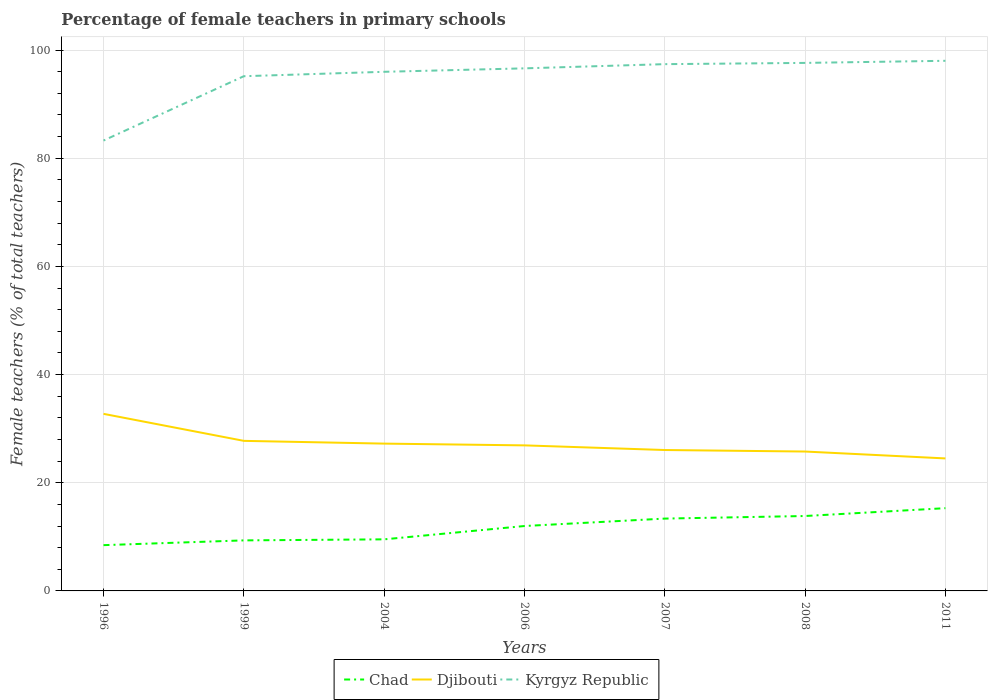Is the number of lines equal to the number of legend labels?
Give a very brief answer. Yes. Across all years, what is the maximum percentage of female teachers in Chad?
Offer a terse response. 8.46. What is the total percentage of female teachers in Kyrgyz Republic in the graph?
Offer a very short reply. -0.62. What is the difference between the highest and the second highest percentage of female teachers in Chad?
Provide a short and direct response. 6.84. What is the difference between the highest and the lowest percentage of female teachers in Kyrgyz Republic?
Offer a terse response. 6. How many years are there in the graph?
Make the answer very short. 7. What is the difference between two consecutive major ticks on the Y-axis?
Offer a terse response. 20. Does the graph contain any zero values?
Provide a succinct answer. No. Where does the legend appear in the graph?
Your answer should be compact. Bottom center. What is the title of the graph?
Offer a terse response. Percentage of female teachers in primary schools. Does "Sao Tome and Principe" appear as one of the legend labels in the graph?
Your response must be concise. No. What is the label or title of the Y-axis?
Your answer should be very brief. Female teachers (% of total teachers). What is the Female teachers (% of total teachers) in Chad in 1996?
Make the answer very short. 8.46. What is the Female teachers (% of total teachers) in Djibouti in 1996?
Ensure brevity in your answer.  32.74. What is the Female teachers (% of total teachers) of Kyrgyz Republic in 1996?
Your response must be concise. 83.26. What is the Female teachers (% of total teachers) of Chad in 1999?
Ensure brevity in your answer.  9.34. What is the Female teachers (% of total teachers) in Djibouti in 1999?
Make the answer very short. 27.74. What is the Female teachers (% of total teachers) in Kyrgyz Republic in 1999?
Your response must be concise. 95.15. What is the Female teachers (% of total teachers) in Chad in 2004?
Your answer should be compact. 9.54. What is the Female teachers (% of total teachers) of Djibouti in 2004?
Your answer should be compact. 27.23. What is the Female teachers (% of total teachers) of Kyrgyz Republic in 2004?
Make the answer very short. 95.97. What is the Female teachers (% of total teachers) of Chad in 2006?
Provide a short and direct response. 12. What is the Female teachers (% of total teachers) in Djibouti in 2006?
Provide a short and direct response. 26.91. What is the Female teachers (% of total teachers) in Kyrgyz Republic in 2006?
Your answer should be very brief. 96.61. What is the Female teachers (% of total teachers) in Chad in 2007?
Keep it short and to the point. 13.37. What is the Female teachers (% of total teachers) of Djibouti in 2007?
Your answer should be compact. 26.05. What is the Female teachers (% of total teachers) of Kyrgyz Republic in 2007?
Provide a short and direct response. 97.38. What is the Female teachers (% of total teachers) of Chad in 2008?
Provide a succinct answer. 13.85. What is the Female teachers (% of total teachers) of Djibouti in 2008?
Provide a succinct answer. 25.77. What is the Female teachers (% of total teachers) in Kyrgyz Republic in 2008?
Ensure brevity in your answer.  97.62. What is the Female teachers (% of total teachers) in Chad in 2011?
Ensure brevity in your answer.  15.3. What is the Female teachers (% of total teachers) of Djibouti in 2011?
Ensure brevity in your answer.  24.49. What is the Female teachers (% of total teachers) in Kyrgyz Republic in 2011?
Give a very brief answer. 98.01. Across all years, what is the maximum Female teachers (% of total teachers) in Chad?
Provide a short and direct response. 15.3. Across all years, what is the maximum Female teachers (% of total teachers) in Djibouti?
Give a very brief answer. 32.74. Across all years, what is the maximum Female teachers (% of total teachers) of Kyrgyz Republic?
Keep it short and to the point. 98.01. Across all years, what is the minimum Female teachers (% of total teachers) in Chad?
Your answer should be very brief. 8.46. Across all years, what is the minimum Female teachers (% of total teachers) of Djibouti?
Offer a very short reply. 24.49. Across all years, what is the minimum Female teachers (% of total teachers) in Kyrgyz Republic?
Your answer should be very brief. 83.26. What is the total Female teachers (% of total teachers) in Chad in the graph?
Offer a very short reply. 81.86. What is the total Female teachers (% of total teachers) in Djibouti in the graph?
Make the answer very short. 190.94. What is the total Female teachers (% of total teachers) in Kyrgyz Republic in the graph?
Keep it short and to the point. 664. What is the difference between the Female teachers (% of total teachers) in Chad in 1996 and that in 1999?
Your response must be concise. -0.88. What is the difference between the Female teachers (% of total teachers) in Djibouti in 1996 and that in 1999?
Ensure brevity in your answer.  4.99. What is the difference between the Female teachers (% of total teachers) of Kyrgyz Republic in 1996 and that in 1999?
Provide a succinct answer. -11.89. What is the difference between the Female teachers (% of total teachers) in Chad in 1996 and that in 2004?
Ensure brevity in your answer.  -1.07. What is the difference between the Female teachers (% of total teachers) of Djibouti in 1996 and that in 2004?
Provide a succinct answer. 5.5. What is the difference between the Female teachers (% of total teachers) of Kyrgyz Republic in 1996 and that in 2004?
Ensure brevity in your answer.  -12.71. What is the difference between the Female teachers (% of total teachers) in Chad in 1996 and that in 2006?
Your response must be concise. -3.54. What is the difference between the Female teachers (% of total teachers) of Djibouti in 1996 and that in 2006?
Provide a succinct answer. 5.83. What is the difference between the Female teachers (% of total teachers) of Kyrgyz Republic in 1996 and that in 2006?
Provide a succinct answer. -13.35. What is the difference between the Female teachers (% of total teachers) of Chad in 1996 and that in 2007?
Ensure brevity in your answer.  -4.91. What is the difference between the Female teachers (% of total teachers) in Djibouti in 1996 and that in 2007?
Your answer should be compact. 6.69. What is the difference between the Female teachers (% of total teachers) in Kyrgyz Republic in 1996 and that in 2007?
Provide a succinct answer. -14.12. What is the difference between the Female teachers (% of total teachers) in Chad in 1996 and that in 2008?
Keep it short and to the point. -5.39. What is the difference between the Female teachers (% of total teachers) in Djibouti in 1996 and that in 2008?
Offer a very short reply. 6.97. What is the difference between the Female teachers (% of total teachers) in Kyrgyz Republic in 1996 and that in 2008?
Give a very brief answer. -14.36. What is the difference between the Female teachers (% of total teachers) of Chad in 1996 and that in 2011?
Keep it short and to the point. -6.84. What is the difference between the Female teachers (% of total teachers) of Djibouti in 1996 and that in 2011?
Your response must be concise. 8.24. What is the difference between the Female teachers (% of total teachers) in Kyrgyz Republic in 1996 and that in 2011?
Provide a succinct answer. -14.75. What is the difference between the Female teachers (% of total teachers) in Chad in 1999 and that in 2004?
Give a very brief answer. -0.19. What is the difference between the Female teachers (% of total teachers) of Djibouti in 1999 and that in 2004?
Give a very brief answer. 0.51. What is the difference between the Female teachers (% of total teachers) in Kyrgyz Republic in 1999 and that in 2004?
Your answer should be compact. -0.82. What is the difference between the Female teachers (% of total teachers) of Chad in 1999 and that in 2006?
Provide a succinct answer. -2.66. What is the difference between the Female teachers (% of total teachers) in Djibouti in 1999 and that in 2006?
Give a very brief answer. 0.83. What is the difference between the Female teachers (% of total teachers) of Kyrgyz Republic in 1999 and that in 2006?
Your answer should be very brief. -1.45. What is the difference between the Female teachers (% of total teachers) of Chad in 1999 and that in 2007?
Ensure brevity in your answer.  -4.03. What is the difference between the Female teachers (% of total teachers) in Djibouti in 1999 and that in 2007?
Make the answer very short. 1.69. What is the difference between the Female teachers (% of total teachers) in Kyrgyz Republic in 1999 and that in 2007?
Provide a succinct answer. -2.23. What is the difference between the Female teachers (% of total teachers) in Chad in 1999 and that in 2008?
Offer a terse response. -4.51. What is the difference between the Female teachers (% of total teachers) in Djibouti in 1999 and that in 2008?
Ensure brevity in your answer.  1.97. What is the difference between the Female teachers (% of total teachers) of Kyrgyz Republic in 1999 and that in 2008?
Give a very brief answer. -2.46. What is the difference between the Female teachers (% of total teachers) of Chad in 1999 and that in 2011?
Provide a succinct answer. -5.96. What is the difference between the Female teachers (% of total teachers) in Djibouti in 1999 and that in 2011?
Your response must be concise. 3.25. What is the difference between the Female teachers (% of total teachers) in Kyrgyz Republic in 1999 and that in 2011?
Provide a succinct answer. -2.85. What is the difference between the Female teachers (% of total teachers) of Chad in 2004 and that in 2006?
Provide a short and direct response. -2.46. What is the difference between the Female teachers (% of total teachers) in Djibouti in 2004 and that in 2006?
Make the answer very short. 0.33. What is the difference between the Female teachers (% of total teachers) of Kyrgyz Republic in 2004 and that in 2006?
Your answer should be compact. -0.64. What is the difference between the Female teachers (% of total teachers) in Chad in 2004 and that in 2007?
Ensure brevity in your answer.  -3.84. What is the difference between the Female teachers (% of total teachers) in Djibouti in 2004 and that in 2007?
Ensure brevity in your answer.  1.19. What is the difference between the Female teachers (% of total teachers) in Kyrgyz Republic in 2004 and that in 2007?
Provide a succinct answer. -1.41. What is the difference between the Female teachers (% of total teachers) of Chad in 2004 and that in 2008?
Offer a very short reply. -4.31. What is the difference between the Female teachers (% of total teachers) of Djibouti in 2004 and that in 2008?
Your answer should be very brief. 1.46. What is the difference between the Female teachers (% of total teachers) of Kyrgyz Republic in 2004 and that in 2008?
Your response must be concise. -1.64. What is the difference between the Female teachers (% of total teachers) in Chad in 2004 and that in 2011?
Your answer should be very brief. -5.76. What is the difference between the Female teachers (% of total teachers) in Djibouti in 2004 and that in 2011?
Offer a terse response. 2.74. What is the difference between the Female teachers (% of total teachers) in Kyrgyz Republic in 2004 and that in 2011?
Provide a short and direct response. -2.03. What is the difference between the Female teachers (% of total teachers) in Chad in 2006 and that in 2007?
Offer a very short reply. -1.37. What is the difference between the Female teachers (% of total teachers) of Djibouti in 2006 and that in 2007?
Give a very brief answer. 0.86. What is the difference between the Female teachers (% of total teachers) in Kyrgyz Republic in 2006 and that in 2007?
Offer a very short reply. -0.78. What is the difference between the Female teachers (% of total teachers) of Chad in 2006 and that in 2008?
Make the answer very short. -1.85. What is the difference between the Female teachers (% of total teachers) of Djibouti in 2006 and that in 2008?
Keep it short and to the point. 1.14. What is the difference between the Female teachers (% of total teachers) in Kyrgyz Republic in 2006 and that in 2008?
Your answer should be compact. -1.01. What is the difference between the Female teachers (% of total teachers) in Chad in 2006 and that in 2011?
Your answer should be very brief. -3.3. What is the difference between the Female teachers (% of total teachers) in Djibouti in 2006 and that in 2011?
Make the answer very short. 2.41. What is the difference between the Female teachers (% of total teachers) of Kyrgyz Republic in 2006 and that in 2011?
Your response must be concise. -1.4. What is the difference between the Female teachers (% of total teachers) in Chad in 2007 and that in 2008?
Offer a terse response. -0.48. What is the difference between the Female teachers (% of total teachers) of Djibouti in 2007 and that in 2008?
Your answer should be very brief. 0.28. What is the difference between the Female teachers (% of total teachers) in Kyrgyz Republic in 2007 and that in 2008?
Your response must be concise. -0.23. What is the difference between the Female teachers (% of total teachers) of Chad in 2007 and that in 2011?
Provide a succinct answer. -1.93. What is the difference between the Female teachers (% of total teachers) in Djibouti in 2007 and that in 2011?
Provide a short and direct response. 1.55. What is the difference between the Female teachers (% of total teachers) of Kyrgyz Republic in 2007 and that in 2011?
Provide a short and direct response. -0.62. What is the difference between the Female teachers (% of total teachers) of Chad in 2008 and that in 2011?
Ensure brevity in your answer.  -1.45. What is the difference between the Female teachers (% of total teachers) in Djibouti in 2008 and that in 2011?
Your answer should be very brief. 1.27. What is the difference between the Female teachers (% of total teachers) of Kyrgyz Republic in 2008 and that in 2011?
Ensure brevity in your answer.  -0.39. What is the difference between the Female teachers (% of total teachers) in Chad in 1996 and the Female teachers (% of total teachers) in Djibouti in 1999?
Your response must be concise. -19.28. What is the difference between the Female teachers (% of total teachers) of Chad in 1996 and the Female teachers (% of total teachers) of Kyrgyz Republic in 1999?
Keep it short and to the point. -86.69. What is the difference between the Female teachers (% of total teachers) of Djibouti in 1996 and the Female teachers (% of total teachers) of Kyrgyz Republic in 1999?
Offer a very short reply. -62.42. What is the difference between the Female teachers (% of total teachers) in Chad in 1996 and the Female teachers (% of total teachers) in Djibouti in 2004?
Your response must be concise. -18.77. What is the difference between the Female teachers (% of total teachers) in Chad in 1996 and the Female teachers (% of total teachers) in Kyrgyz Republic in 2004?
Give a very brief answer. -87.51. What is the difference between the Female teachers (% of total teachers) of Djibouti in 1996 and the Female teachers (% of total teachers) of Kyrgyz Republic in 2004?
Your response must be concise. -63.23. What is the difference between the Female teachers (% of total teachers) in Chad in 1996 and the Female teachers (% of total teachers) in Djibouti in 2006?
Provide a succinct answer. -18.45. What is the difference between the Female teachers (% of total teachers) of Chad in 1996 and the Female teachers (% of total teachers) of Kyrgyz Republic in 2006?
Offer a terse response. -88.15. What is the difference between the Female teachers (% of total teachers) of Djibouti in 1996 and the Female teachers (% of total teachers) of Kyrgyz Republic in 2006?
Offer a very short reply. -63.87. What is the difference between the Female teachers (% of total teachers) of Chad in 1996 and the Female teachers (% of total teachers) of Djibouti in 2007?
Provide a short and direct response. -17.59. What is the difference between the Female teachers (% of total teachers) in Chad in 1996 and the Female teachers (% of total teachers) in Kyrgyz Republic in 2007?
Offer a terse response. -88.92. What is the difference between the Female teachers (% of total teachers) of Djibouti in 1996 and the Female teachers (% of total teachers) of Kyrgyz Republic in 2007?
Your answer should be very brief. -64.65. What is the difference between the Female teachers (% of total teachers) of Chad in 1996 and the Female teachers (% of total teachers) of Djibouti in 2008?
Give a very brief answer. -17.31. What is the difference between the Female teachers (% of total teachers) of Chad in 1996 and the Female teachers (% of total teachers) of Kyrgyz Republic in 2008?
Provide a succinct answer. -89.15. What is the difference between the Female teachers (% of total teachers) in Djibouti in 1996 and the Female teachers (% of total teachers) in Kyrgyz Republic in 2008?
Make the answer very short. -64.88. What is the difference between the Female teachers (% of total teachers) of Chad in 1996 and the Female teachers (% of total teachers) of Djibouti in 2011?
Your answer should be compact. -16.03. What is the difference between the Female teachers (% of total teachers) in Chad in 1996 and the Female teachers (% of total teachers) in Kyrgyz Republic in 2011?
Provide a short and direct response. -89.54. What is the difference between the Female teachers (% of total teachers) of Djibouti in 1996 and the Female teachers (% of total teachers) of Kyrgyz Republic in 2011?
Give a very brief answer. -65.27. What is the difference between the Female teachers (% of total teachers) of Chad in 1999 and the Female teachers (% of total teachers) of Djibouti in 2004?
Ensure brevity in your answer.  -17.89. What is the difference between the Female teachers (% of total teachers) in Chad in 1999 and the Female teachers (% of total teachers) in Kyrgyz Republic in 2004?
Make the answer very short. -86.63. What is the difference between the Female teachers (% of total teachers) in Djibouti in 1999 and the Female teachers (% of total teachers) in Kyrgyz Republic in 2004?
Provide a succinct answer. -68.23. What is the difference between the Female teachers (% of total teachers) of Chad in 1999 and the Female teachers (% of total teachers) of Djibouti in 2006?
Your answer should be very brief. -17.57. What is the difference between the Female teachers (% of total teachers) in Chad in 1999 and the Female teachers (% of total teachers) in Kyrgyz Republic in 2006?
Give a very brief answer. -87.27. What is the difference between the Female teachers (% of total teachers) of Djibouti in 1999 and the Female teachers (% of total teachers) of Kyrgyz Republic in 2006?
Keep it short and to the point. -68.87. What is the difference between the Female teachers (% of total teachers) of Chad in 1999 and the Female teachers (% of total teachers) of Djibouti in 2007?
Offer a very short reply. -16.71. What is the difference between the Female teachers (% of total teachers) in Chad in 1999 and the Female teachers (% of total teachers) in Kyrgyz Republic in 2007?
Your answer should be very brief. -88.04. What is the difference between the Female teachers (% of total teachers) in Djibouti in 1999 and the Female teachers (% of total teachers) in Kyrgyz Republic in 2007?
Your answer should be compact. -69.64. What is the difference between the Female teachers (% of total teachers) of Chad in 1999 and the Female teachers (% of total teachers) of Djibouti in 2008?
Your answer should be compact. -16.43. What is the difference between the Female teachers (% of total teachers) of Chad in 1999 and the Female teachers (% of total teachers) of Kyrgyz Republic in 2008?
Make the answer very short. -88.27. What is the difference between the Female teachers (% of total teachers) in Djibouti in 1999 and the Female teachers (% of total teachers) in Kyrgyz Republic in 2008?
Provide a succinct answer. -69.87. What is the difference between the Female teachers (% of total teachers) of Chad in 1999 and the Female teachers (% of total teachers) of Djibouti in 2011?
Make the answer very short. -15.15. What is the difference between the Female teachers (% of total teachers) in Chad in 1999 and the Female teachers (% of total teachers) in Kyrgyz Republic in 2011?
Your answer should be very brief. -88.66. What is the difference between the Female teachers (% of total teachers) in Djibouti in 1999 and the Female teachers (% of total teachers) in Kyrgyz Republic in 2011?
Your answer should be very brief. -70.26. What is the difference between the Female teachers (% of total teachers) of Chad in 2004 and the Female teachers (% of total teachers) of Djibouti in 2006?
Ensure brevity in your answer.  -17.37. What is the difference between the Female teachers (% of total teachers) in Chad in 2004 and the Female teachers (% of total teachers) in Kyrgyz Republic in 2006?
Your answer should be very brief. -87.07. What is the difference between the Female teachers (% of total teachers) of Djibouti in 2004 and the Female teachers (% of total teachers) of Kyrgyz Republic in 2006?
Make the answer very short. -69.37. What is the difference between the Female teachers (% of total teachers) of Chad in 2004 and the Female teachers (% of total teachers) of Djibouti in 2007?
Your answer should be very brief. -16.51. What is the difference between the Female teachers (% of total teachers) of Chad in 2004 and the Female teachers (% of total teachers) of Kyrgyz Republic in 2007?
Provide a short and direct response. -87.85. What is the difference between the Female teachers (% of total teachers) in Djibouti in 2004 and the Female teachers (% of total teachers) in Kyrgyz Republic in 2007?
Provide a short and direct response. -70.15. What is the difference between the Female teachers (% of total teachers) in Chad in 2004 and the Female teachers (% of total teachers) in Djibouti in 2008?
Offer a very short reply. -16.23. What is the difference between the Female teachers (% of total teachers) of Chad in 2004 and the Female teachers (% of total teachers) of Kyrgyz Republic in 2008?
Give a very brief answer. -88.08. What is the difference between the Female teachers (% of total teachers) of Djibouti in 2004 and the Female teachers (% of total teachers) of Kyrgyz Republic in 2008?
Your response must be concise. -70.38. What is the difference between the Female teachers (% of total teachers) of Chad in 2004 and the Female teachers (% of total teachers) of Djibouti in 2011?
Provide a succinct answer. -14.96. What is the difference between the Female teachers (% of total teachers) of Chad in 2004 and the Female teachers (% of total teachers) of Kyrgyz Republic in 2011?
Make the answer very short. -88.47. What is the difference between the Female teachers (% of total teachers) in Djibouti in 2004 and the Female teachers (% of total teachers) in Kyrgyz Republic in 2011?
Your response must be concise. -70.77. What is the difference between the Female teachers (% of total teachers) of Chad in 2006 and the Female teachers (% of total teachers) of Djibouti in 2007?
Keep it short and to the point. -14.05. What is the difference between the Female teachers (% of total teachers) in Chad in 2006 and the Female teachers (% of total teachers) in Kyrgyz Republic in 2007?
Give a very brief answer. -85.39. What is the difference between the Female teachers (% of total teachers) in Djibouti in 2006 and the Female teachers (% of total teachers) in Kyrgyz Republic in 2007?
Offer a terse response. -70.48. What is the difference between the Female teachers (% of total teachers) of Chad in 2006 and the Female teachers (% of total teachers) of Djibouti in 2008?
Ensure brevity in your answer.  -13.77. What is the difference between the Female teachers (% of total teachers) of Chad in 2006 and the Female teachers (% of total teachers) of Kyrgyz Republic in 2008?
Keep it short and to the point. -85.62. What is the difference between the Female teachers (% of total teachers) in Djibouti in 2006 and the Female teachers (% of total teachers) in Kyrgyz Republic in 2008?
Keep it short and to the point. -70.71. What is the difference between the Female teachers (% of total teachers) in Chad in 2006 and the Female teachers (% of total teachers) in Djibouti in 2011?
Your response must be concise. -12.5. What is the difference between the Female teachers (% of total teachers) in Chad in 2006 and the Female teachers (% of total teachers) in Kyrgyz Republic in 2011?
Your answer should be compact. -86.01. What is the difference between the Female teachers (% of total teachers) in Djibouti in 2006 and the Female teachers (% of total teachers) in Kyrgyz Republic in 2011?
Offer a terse response. -71.1. What is the difference between the Female teachers (% of total teachers) of Chad in 2007 and the Female teachers (% of total teachers) of Djibouti in 2008?
Make the answer very short. -12.4. What is the difference between the Female teachers (% of total teachers) of Chad in 2007 and the Female teachers (% of total teachers) of Kyrgyz Republic in 2008?
Your answer should be compact. -84.24. What is the difference between the Female teachers (% of total teachers) in Djibouti in 2007 and the Female teachers (% of total teachers) in Kyrgyz Republic in 2008?
Keep it short and to the point. -71.57. What is the difference between the Female teachers (% of total teachers) in Chad in 2007 and the Female teachers (% of total teachers) in Djibouti in 2011?
Keep it short and to the point. -11.12. What is the difference between the Female teachers (% of total teachers) of Chad in 2007 and the Female teachers (% of total teachers) of Kyrgyz Republic in 2011?
Your answer should be compact. -84.63. What is the difference between the Female teachers (% of total teachers) of Djibouti in 2007 and the Female teachers (% of total teachers) of Kyrgyz Republic in 2011?
Your response must be concise. -71.96. What is the difference between the Female teachers (% of total teachers) of Chad in 2008 and the Female teachers (% of total teachers) of Djibouti in 2011?
Provide a short and direct response. -10.65. What is the difference between the Female teachers (% of total teachers) in Chad in 2008 and the Female teachers (% of total teachers) in Kyrgyz Republic in 2011?
Provide a succinct answer. -84.16. What is the difference between the Female teachers (% of total teachers) of Djibouti in 2008 and the Female teachers (% of total teachers) of Kyrgyz Republic in 2011?
Provide a short and direct response. -72.24. What is the average Female teachers (% of total teachers) of Chad per year?
Ensure brevity in your answer.  11.69. What is the average Female teachers (% of total teachers) in Djibouti per year?
Make the answer very short. 27.28. What is the average Female teachers (% of total teachers) of Kyrgyz Republic per year?
Offer a terse response. 94.86. In the year 1996, what is the difference between the Female teachers (% of total teachers) of Chad and Female teachers (% of total teachers) of Djibouti?
Give a very brief answer. -24.27. In the year 1996, what is the difference between the Female teachers (% of total teachers) in Chad and Female teachers (% of total teachers) in Kyrgyz Republic?
Your answer should be compact. -74.8. In the year 1996, what is the difference between the Female teachers (% of total teachers) of Djibouti and Female teachers (% of total teachers) of Kyrgyz Republic?
Your answer should be very brief. -50.52. In the year 1999, what is the difference between the Female teachers (% of total teachers) in Chad and Female teachers (% of total teachers) in Djibouti?
Keep it short and to the point. -18.4. In the year 1999, what is the difference between the Female teachers (% of total teachers) of Chad and Female teachers (% of total teachers) of Kyrgyz Republic?
Offer a terse response. -85.81. In the year 1999, what is the difference between the Female teachers (% of total teachers) in Djibouti and Female teachers (% of total teachers) in Kyrgyz Republic?
Offer a terse response. -67.41. In the year 2004, what is the difference between the Female teachers (% of total teachers) of Chad and Female teachers (% of total teachers) of Djibouti?
Make the answer very short. -17.7. In the year 2004, what is the difference between the Female teachers (% of total teachers) in Chad and Female teachers (% of total teachers) in Kyrgyz Republic?
Give a very brief answer. -86.44. In the year 2004, what is the difference between the Female teachers (% of total teachers) in Djibouti and Female teachers (% of total teachers) in Kyrgyz Republic?
Provide a short and direct response. -68.74. In the year 2006, what is the difference between the Female teachers (% of total teachers) in Chad and Female teachers (% of total teachers) in Djibouti?
Ensure brevity in your answer.  -14.91. In the year 2006, what is the difference between the Female teachers (% of total teachers) in Chad and Female teachers (% of total teachers) in Kyrgyz Republic?
Your answer should be compact. -84.61. In the year 2006, what is the difference between the Female teachers (% of total teachers) in Djibouti and Female teachers (% of total teachers) in Kyrgyz Republic?
Offer a terse response. -69.7. In the year 2007, what is the difference between the Female teachers (% of total teachers) in Chad and Female teachers (% of total teachers) in Djibouti?
Offer a terse response. -12.68. In the year 2007, what is the difference between the Female teachers (% of total teachers) in Chad and Female teachers (% of total teachers) in Kyrgyz Republic?
Provide a succinct answer. -84.01. In the year 2007, what is the difference between the Female teachers (% of total teachers) of Djibouti and Female teachers (% of total teachers) of Kyrgyz Republic?
Ensure brevity in your answer.  -71.34. In the year 2008, what is the difference between the Female teachers (% of total teachers) of Chad and Female teachers (% of total teachers) of Djibouti?
Provide a succinct answer. -11.92. In the year 2008, what is the difference between the Female teachers (% of total teachers) of Chad and Female teachers (% of total teachers) of Kyrgyz Republic?
Your response must be concise. -83.77. In the year 2008, what is the difference between the Female teachers (% of total teachers) of Djibouti and Female teachers (% of total teachers) of Kyrgyz Republic?
Offer a very short reply. -71.85. In the year 2011, what is the difference between the Female teachers (% of total teachers) of Chad and Female teachers (% of total teachers) of Djibouti?
Provide a succinct answer. -9.2. In the year 2011, what is the difference between the Female teachers (% of total teachers) in Chad and Female teachers (% of total teachers) in Kyrgyz Republic?
Offer a very short reply. -82.71. In the year 2011, what is the difference between the Female teachers (% of total teachers) in Djibouti and Female teachers (% of total teachers) in Kyrgyz Republic?
Make the answer very short. -73.51. What is the ratio of the Female teachers (% of total teachers) of Chad in 1996 to that in 1999?
Make the answer very short. 0.91. What is the ratio of the Female teachers (% of total teachers) in Djibouti in 1996 to that in 1999?
Offer a very short reply. 1.18. What is the ratio of the Female teachers (% of total teachers) in Kyrgyz Republic in 1996 to that in 1999?
Your answer should be compact. 0.88. What is the ratio of the Female teachers (% of total teachers) in Chad in 1996 to that in 2004?
Make the answer very short. 0.89. What is the ratio of the Female teachers (% of total teachers) of Djibouti in 1996 to that in 2004?
Make the answer very short. 1.2. What is the ratio of the Female teachers (% of total teachers) in Kyrgyz Republic in 1996 to that in 2004?
Give a very brief answer. 0.87. What is the ratio of the Female teachers (% of total teachers) of Chad in 1996 to that in 2006?
Make the answer very short. 0.71. What is the ratio of the Female teachers (% of total teachers) of Djibouti in 1996 to that in 2006?
Provide a short and direct response. 1.22. What is the ratio of the Female teachers (% of total teachers) in Kyrgyz Republic in 1996 to that in 2006?
Provide a short and direct response. 0.86. What is the ratio of the Female teachers (% of total teachers) in Chad in 1996 to that in 2007?
Your answer should be compact. 0.63. What is the ratio of the Female teachers (% of total teachers) of Djibouti in 1996 to that in 2007?
Offer a terse response. 1.26. What is the ratio of the Female teachers (% of total teachers) of Kyrgyz Republic in 1996 to that in 2007?
Offer a terse response. 0.85. What is the ratio of the Female teachers (% of total teachers) of Chad in 1996 to that in 2008?
Your response must be concise. 0.61. What is the ratio of the Female teachers (% of total teachers) in Djibouti in 1996 to that in 2008?
Give a very brief answer. 1.27. What is the ratio of the Female teachers (% of total teachers) in Kyrgyz Republic in 1996 to that in 2008?
Your answer should be compact. 0.85. What is the ratio of the Female teachers (% of total teachers) in Chad in 1996 to that in 2011?
Ensure brevity in your answer.  0.55. What is the ratio of the Female teachers (% of total teachers) in Djibouti in 1996 to that in 2011?
Your response must be concise. 1.34. What is the ratio of the Female teachers (% of total teachers) in Kyrgyz Republic in 1996 to that in 2011?
Provide a succinct answer. 0.85. What is the ratio of the Female teachers (% of total teachers) in Chad in 1999 to that in 2004?
Your response must be concise. 0.98. What is the ratio of the Female teachers (% of total teachers) in Djibouti in 1999 to that in 2004?
Give a very brief answer. 1.02. What is the ratio of the Female teachers (% of total teachers) in Kyrgyz Republic in 1999 to that in 2004?
Give a very brief answer. 0.99. What is the ratio of the Female teachers (% of total teachers) of Chad in 1999 to that in 2006?
Offer a very short reply. 0.78. What is the ratio of the Female teachers (% of total teachers) in Djibouti in 1999 to that in 2006?
Your answer should be compact. 1.03. What is the ratio of the Female teachers (% of total teachers) in Kyrgyz Republic in 1999 to that in 2006?
Give a very brief answer. 0.98. What is the ratio of the Female teachers (% of total teachers) of Chad in 1999 to that in 2007?
Keep it short and to the point. 0.7. What is the ratio of the Female teachers (% of total teachers) of Djibouti in 1999 to that in 2007?
Your answer should be compact. 1.06. What is the ratio of the Female teachers (% of total teachers) of Kyrgyz Republic in 1999 to that in 2007?
Give a very brief answer. 0.98. What is the ratio of the Female teachers (% of total teachers) of Chad in 1999 to that in 2008?
Make the answer very short. 0.67. What is the ratio of the Female teachers (% of total teachers) of Djibouti in 1999 to that in 2008?
Give a very brief answer. 1.08. What is the ratio of the Female teachers (% of total teachers) in Kyrgyz Republic in 1999 to that in 2008?
Provide a short and direct response. 0.97. What is the ratio of the Female teachers (% of total teachers) of Chad in 1999 to that in 2011?
Your answer should be compact. 0.61. What is the ratio of the Female teachers (% of total teachers) in Djibouti in 1999 to that in 2011?
Ensure brevity in your answer.  1.13. What is the ratio of the Female teachers (% of total teachers) in Kyrgyz Republic in 1999 to that in 2011?
Keep it short and to the point. 0.97. What is the ratio of the Female teachers (% of total teachers) of Chad in 2004 to that in 2006?
Make the answer very short. 0.79. What is the ratio of the Female teachers (% of total teachers) of Djibouti in 2004 to that in 2006?
Your response must be concise. 1.01. What is the ratio of the Female teachers (% of total teachers) of Kyrgyz Republic in 2004 to that in 2006?
Provide a succinct answer. 0.99. What is the ratio of the Female teachers (% of total teachers) of Chad in 2004 to that in 2007?
Your answer should be very brief. 0.71. What is the ratio of the Female teachers (% of total teachers) of Djibouti in 2004 to that in 2007?
Your response must be concise. 1.05. What is the ratio of the Female teachers (% of total teachers) of Kyrgyz Republic in 2004 to that in 2007?
Your answer should be very brief. 0.99. What is the ratio of the Female teachers (% of total teachers) of Chad in 2004 to that in 2008?
Make the answer very short. 0.69. What is the ratio of the Female teachers (% of total teachers) of Djibouti in 2004 to that in 2008?
Your answer should be compact. 1.06. What is the ratio of the Female teachers (% of total teachers) of Kyrgyz Republic in 2004 to that in 2008?
Give a very brief answer. 0.98. What is the ratio of the Female teachers (% of total teachers) of Chad in 2004 to that in 2011?
Make the answer very short. 0.62. What is the ratio of the Female teachers (% of total teachers) in Djibouti in 2004 to that in 2011?
Provide a short and direct response. 1.11. What is the ratio of the Female teachers (% of total teachers) in Kyrgyz Republic in 2004 to that in 2011?
Your answer should be very brief. 0.98. What is the ratio of the Female teachers (% of total teachers) of Chad in 2006 to that in 2007?
Ensure brevity in your answer.  0.9. What is the ratio of the Female teachers (% of total teachers) in Djibouti in 2006 to that in 2007?
Offer a very short reply. 1.03. What is the ratio of the Female teachers (% of total teachers) of Chad in 2006 to that in 2008?
Keep it short and to the point. 0.87. What is the ratio of the Female teachers (% of total teachers) of Djibouti in 2006 to that in 2008?
Your answer should be very brief. 1.04. What is the ratio of the Female teachers (% of total teachers) of Kyrgyz Republic in 2006 to that in 2008?
Provide a short and direct response. 0.99. What is the ratio of the Female teachers (% of total teachers) of Chad in 2006 to that in 2011?
Offer a very short reply. 0.78. What is the ratio of the Female teachers (% of total teachers) of Djibouti in 2006 to that in 2011?
Make the answer very short. 1.1. What is the ratio of the Female teachers (% of total teachers) in Kyrgyz Republic in 2006 to that in 2011?
Ensure brevity in your answer.  0.99. What is the ratio of the Female teachers (% of total teachers) of Chad in 2007 to that in 2008?
Provide a short and direct response. 0.97. What is the ratio of the Female teachers (% of total teachers) in Djibouti in 2007 to that in 2008?
Your answer should be compact. 1.01. What is the ratio of the Female teachers (% of total teachers) of Kyrgyz Republic in 2007 to that in 2008?
Give a very brief answer. 1. What is the ratio of the Female teachers (% of total teachers) of Chad in 2007 to that in 2011?
Offer a very short reply. 0.87. What is the ratio of the Female teachers (% of total teachers) in Djibouti in 2007 to that in 2011?
Provide a short and direct response. 1.06. What is the ratio of the Female teachers (% of total teachers) of Chad in 2008 to that in 2011?
Provide a succinct answer. 0.91. What is the ratio of the Female teachers (% of total teachers) in Djibouti in 2008 to that in 2011?
Give a very brief answer. 1.05. What is the ratio of the Female teachers (% of total teachers) in Kyrgyz Republic in 2008 to that in 2011?
Ensure brevity in your answer.  1. What is the difference between the highest and the second highest Female teachers (% of total teachers) in Chad?
Your answer should be very brief. 1.45. What is the difference between the highest and the second highest Female teachers (% of total teachers) of Djibouti?
Give a very brief answer. 4.99. What is the difference between the highest and the second highest Female teachers (% of total teachers) in Kyrgyz Republic?
Your answer should be compact. 0.39. What is the difference between the highest and the lowest Female teachers (% of total teachers) in Chad?
Your response must be concise. 6.84. What is the difference between the highest and the lowest Female teachers (% of total teachers) of Djibouti?
Provide a short and direct response. 8.24. What is the difference between the highest and the lowest Female teachers (% of total teachers) of Kyrgyz Republic?
Provide a succinct answer. 14.75. 